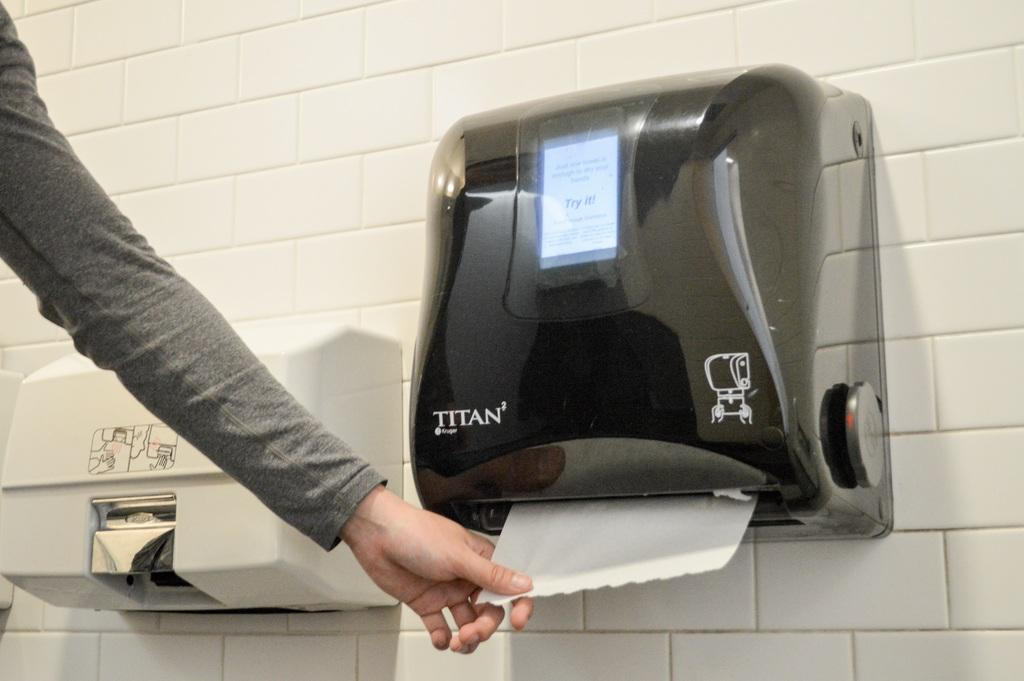What is the main object in the center of the image? There is a tissue holder in the center of the image. Where is the dispenser located in the image? The dispenser is placed on the wall. What can be seen being held by a person's hand in the image? A person's hand is holding a tissue on the left side of the image. What type of scent is emitted from the pail in the image? There is no pail present in the image, so it is not possible to determine any scent associated with it. 